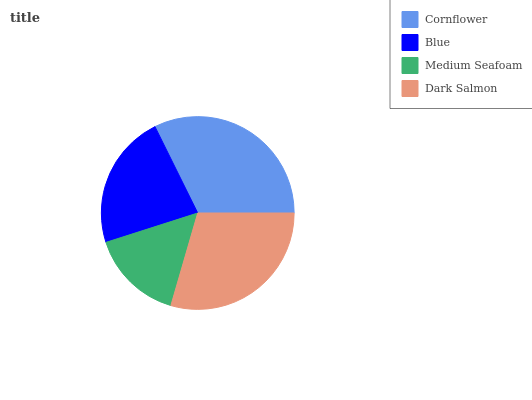Is Medium Seafoam the minimum?
Answer yes or no. Yes. Is Cornflower the maximum?
Answer yes or no. Yes. Is Blue the minimum?
Answer yes or no. No. Is Blue the maximum?
Answer yes or no. No. Is Cornflower greater than Blue?
Answer yes or no. Yes. Is Blue less than Cornflower?
Answer yes or no. Yes. Is Blue greater than Cornflower?
Answer yes or no. No. Is Cornflower less than Blue?
Answer yes or no. No. Is Dark Salmon the high median?
Answer yes or no. Yes. Is Blue the low median?
Answer yes or no. Yes. Is Cornflower the high median?
Answer yes or no. No. Is Cornflower the low median?
Answer yes or no. No. 